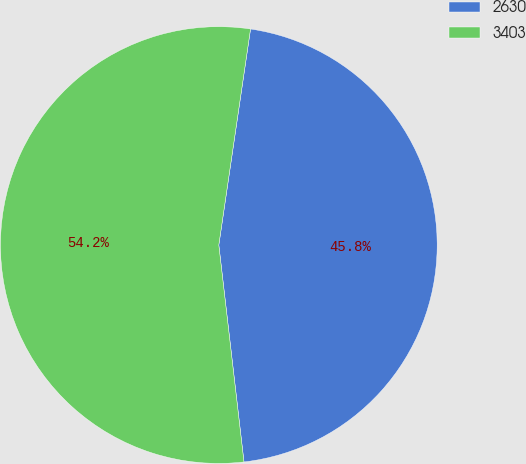Convert chart to OTSL. <chart><loc_0><loc_0><loc_500><loc_500><pie_chart><fcel>2630<fcel>3403<nl><fcel>45.84%<fcel>54.16%<nl></chart> 